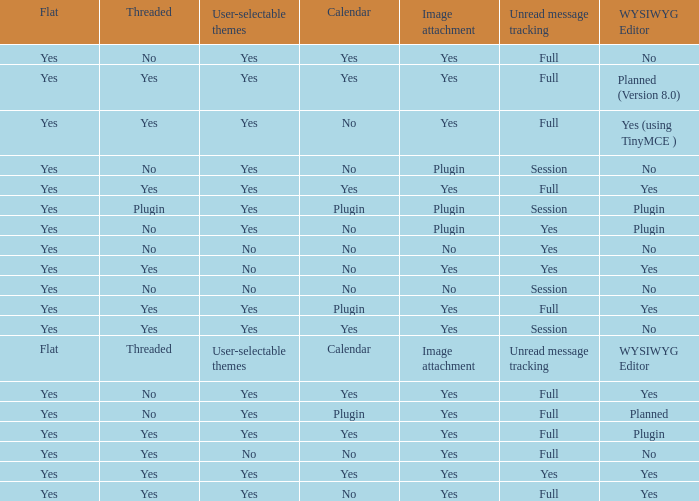Can you give me this table as a dict? {'header': ['Flat', 'Threaded', 'User-selectable themes', 'Calendar', 'Image attachment', 'Unread message tracking', 'WYSIWYG Editor'], 'rows': [['Yes', 'No', 'Yes', 'Yes', 'Yes', 'Full', 'No'], ['Yes', 'Yes', 'Yes', 'Yes', 'Yes', 'Full', 'Planned (Version 8.0)'], ['Yes', 'Yes', 'Yes', 'No', 'Yes', 'Full', 'Yes (using TinyMCE )'], ['Yes', 'No', 'Yes', 'No', 'Plugin', 'Session', 'No'], ['Yes', 'Yes', 'Yes', 'Yes', 'Yes', 'Full', 'Yes'], ['Yes', 'Plugin', 'Yes', 'Plugin', 'Plugin', 'Session', 'Plugin'], ['Yes', 'No', 'Yes', 'No', 'Plugin', 'Yes', 'Plugin'], ['Yes', 'No', 'No', 'No', 'No', 'Yes', 'No'], ['Yes', 'Yes', 'No', 'No', 'Yes', 'Yes', 'Yes'], ['Yes', 'No', 'No', 'No', 'No', 'Session', 'No'], ['Yes', 'Yes', 'Yes', 'Plugin', 'Yes', 'Full', 'Yes'], ['Yes', 'Yes', 'Yes', 'Yes', 'Yes', 'Session', 'No'], ['Flat', 'Threaded', 'User-selectable themes', 'Calendar', 'Image attachment', 'Unread message tracking', 'WYSIWYG Editor'], ['Yes', 'No', 'Yes', 'Yes', 'Yes', 'Full', 'Yes'], ['Yes', 'No', 'Yes', 'Plugin', 'Yes', 'Full', 'Planned'], ['Yes', 'Yes', 'Yes', 'Yes', 'Yes', 'Full', 'Plugin'], ['Yes', 'Yes', 'No', 'No', 'Yes', 'Full', 'No'], ['Yes', 'Yes', 'Yes', 'Yes', 'Yes', 'Yes', 'Yes'], ['Yes', 'Yes', 'Yes', 'No', 'Yes', 'Full', 'Yes']]} Which Calendar has WYSIWYG Editor of yes and an Unread message tracking of yes? Yes, No. 